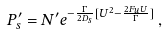Convert formula to latex. <formula><loc_0><loc_0><loc_500><loc_500>P ^ { \prime } _ { s } = N ^ { \prime } e ^ { - \frac { \Gamma } { 2 D _ { s } } [ U ^ { 2 } - \frac { 2 F _ { u } U } { \Gamma } ] } \, ,</formula> 